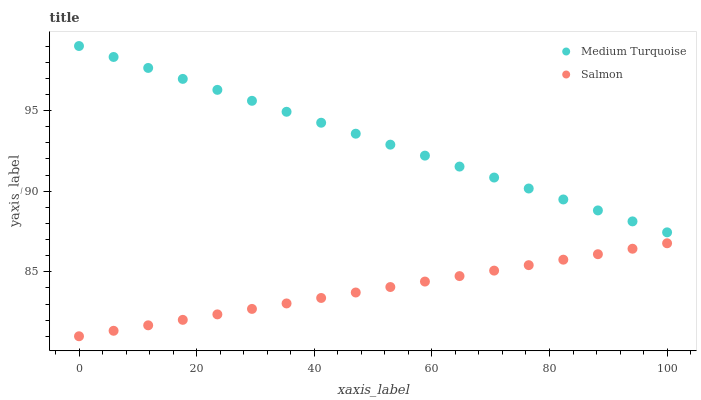Does Salmon have the minimum area under the curve?
Answer yes or no. Yes. Does Medium Turquoise have the maximum area under the curve?
Answer yes or no. Yes. Does Medium Turquoise have the minimum area under the curve?
Answer yes or no. No. Is Medium Turquoise the smoothest?
Answer yes or no. Yes. Is Salmon the roughest?
Answer yes or no. Yes. Is Medium Turquoise the roughest?
Answer yes or no. No. Does Salmon have the lowest value?
Answer yes or no. Yes. Does Medium Turquoise have the lowest value?
Answer yes or no. No. Does Medium Turquoise have the highest value?
Answer yes or no. Yes. Is Salmon less than Medium Turquoise?
Answer yes or no. Yes. Is Medium Turquoise greater than Salmon?
Answer yes or no. Yes. Does Salmon intersect Medium Turquoise?
Answer yes or no. No. 